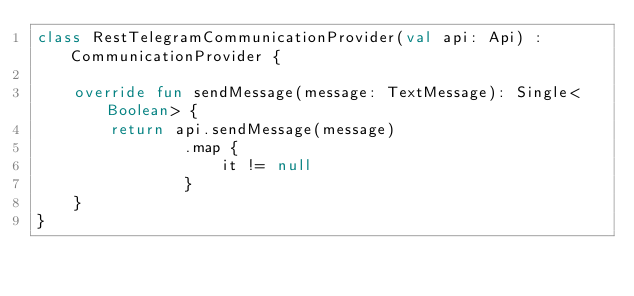Convert code to text. <code><loc_0><loc_0><loc_500><loc_500><_Kotlin_>class RestTelegramCommunicationProvider(val api: Api) : CommunicationProvider {

    override fun sendMessage(message: TextMessage): Single<Boolean> {
        return api.sendMessage(message)
                .map {
                    it != null
                }
    }
}</code> 